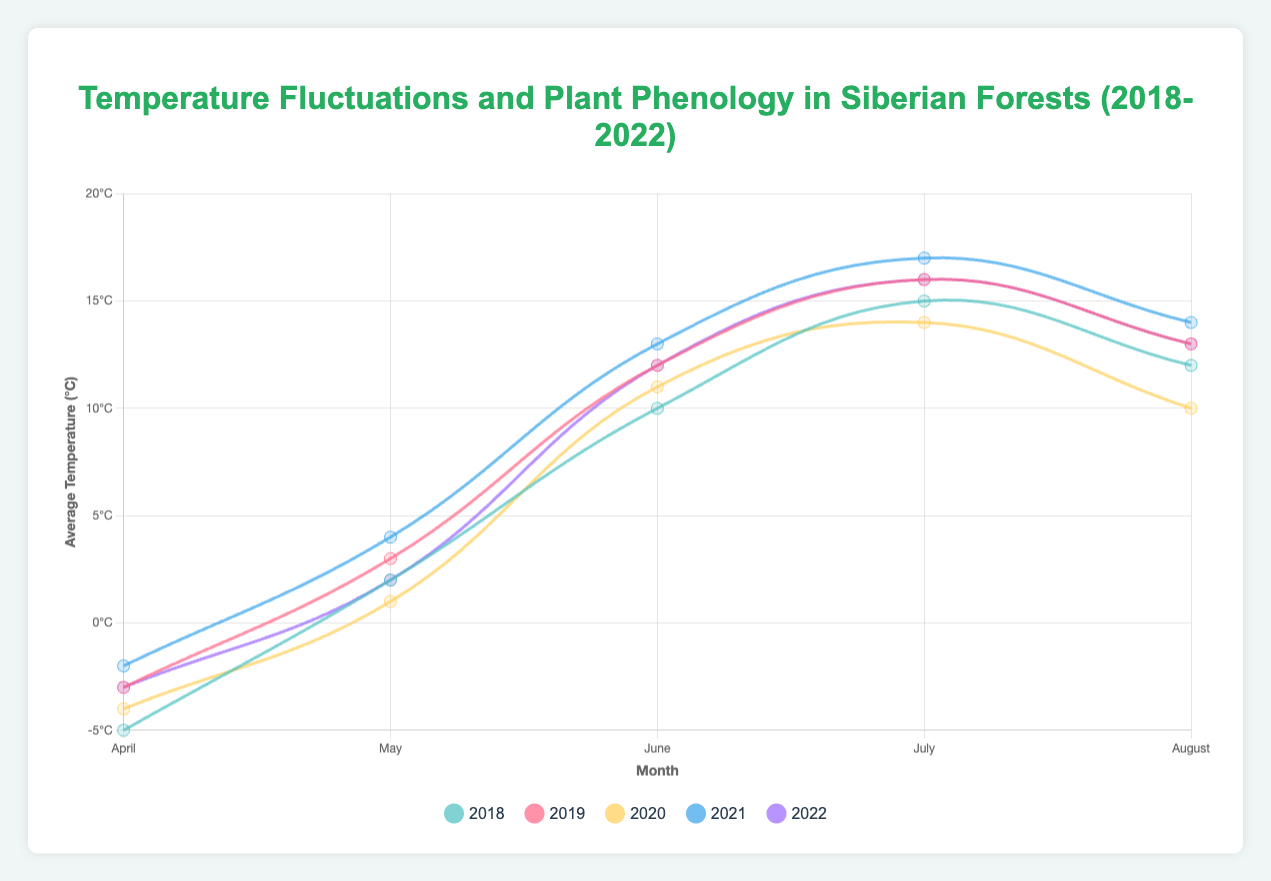What is the average temperature in April across all years? To find the average temperature in April across all years, we sum up the temperatures in April for each year and then divide by the number of years. The temperatures are: -5 (2018), -3 (2019), -4 (2020), -2 (2021), -3 (2022). The sum is -5 + (-3) + (-4) + (-2) + (-3) = -17. Dividing by 5 gives -17/5 = -3.4
Answer: -3.4°C Which year had the highest average temperature in July? To determine which year had the highest average temperature in July, we compare the temperatures for July across all years. These values are: 15 (2018), 16 (2019), 14 (2020), 17 (2021), 16 (2022). The highest temperature is 17°C in 2021.
Answer: 2021 How does the plant phenology phase in June change with increasing temperatures from 2018 to 2022? By examining the phenology phase in June for each year and matching it with the average temperature, we observe the following: 2018: Flowering (10°C), 2019: Flowering (12°C), 2020: Flowering (11°C), 2021: Flowering (13°C), 2022: Flowering (12°C). Despite increasing temperatures, the phenology phase in June consistently remains Flowering.
Answer: Flowering What is the difference in average temperature between June 2018 and June 2021? To find the difference in average temperature between these months, we subtract the temperature in June 2018 from that in June 2021. The temperatures are: 10°C (2018) and 13°C (2021). The difference is 13 - 10 = 3°C.
Answer: 3°C Identify the trend in average temperature for May from 2018 to 2022. Does it increase, decrease, or vary? Checking the average temperatures for May from 2018 to 2022, we have: 2°C (2018), 3°C (2019), 1°C (2020), 4°C (2021), 2°C (2022). The temperatures show a varying trend: an increase from 2018 to 2019, a decrease in 2020, a significant increase in 2021, and a decrease in 2022.
Answer: Varying What is the total sum of average temperatures in June for the years provided? To find the total sum, we add the average temperatures for June from each year: 10°C (2018), 12°C (2019), 11°C (2020), 13°C (2021), 12°C (2022). The sum is 10 + 12 + 11 + 13 + 12 = 58°C.
Answer: 58°C What is the temperature difference between the warmest and coldest months in 2018? The temperatures for 2018 are: April: -5°C, May: 2°C, June: 10°C, July: 15°C, August: 12°C. The warmest month is July at 15°C and the coldest is April at -5°C. The difference is 15 - (-5) = 20°C.
Answer: 20°C In which month did the average temperature increase the most from 2018 to 2019? Comparing the month-wise temperatures from 2018 to 2019: April: -5°C to -3°C = +2°C, May: 2°C to 3°C = +1°C, June: 10°C to 12°C = +2°C, July: 15°C to 16°C = +1°C, August: 12°C to 13°C = +1°C. The largest increase is seen in April and June, both with +2°C.
Answer: April/June What is the overall trend in the plant phenology phase from Budburst to Ripening across the months in 2021? Observing the plant phenology phase for 2021 across the months: April: Budburst, May: Leafing, June: Flowering, July: Seed Setting, August: Ripening. The phases transition logically from Budburst in early spring to Ripening by late summer.
Answer: Logical transition from Budburst to Ripening 